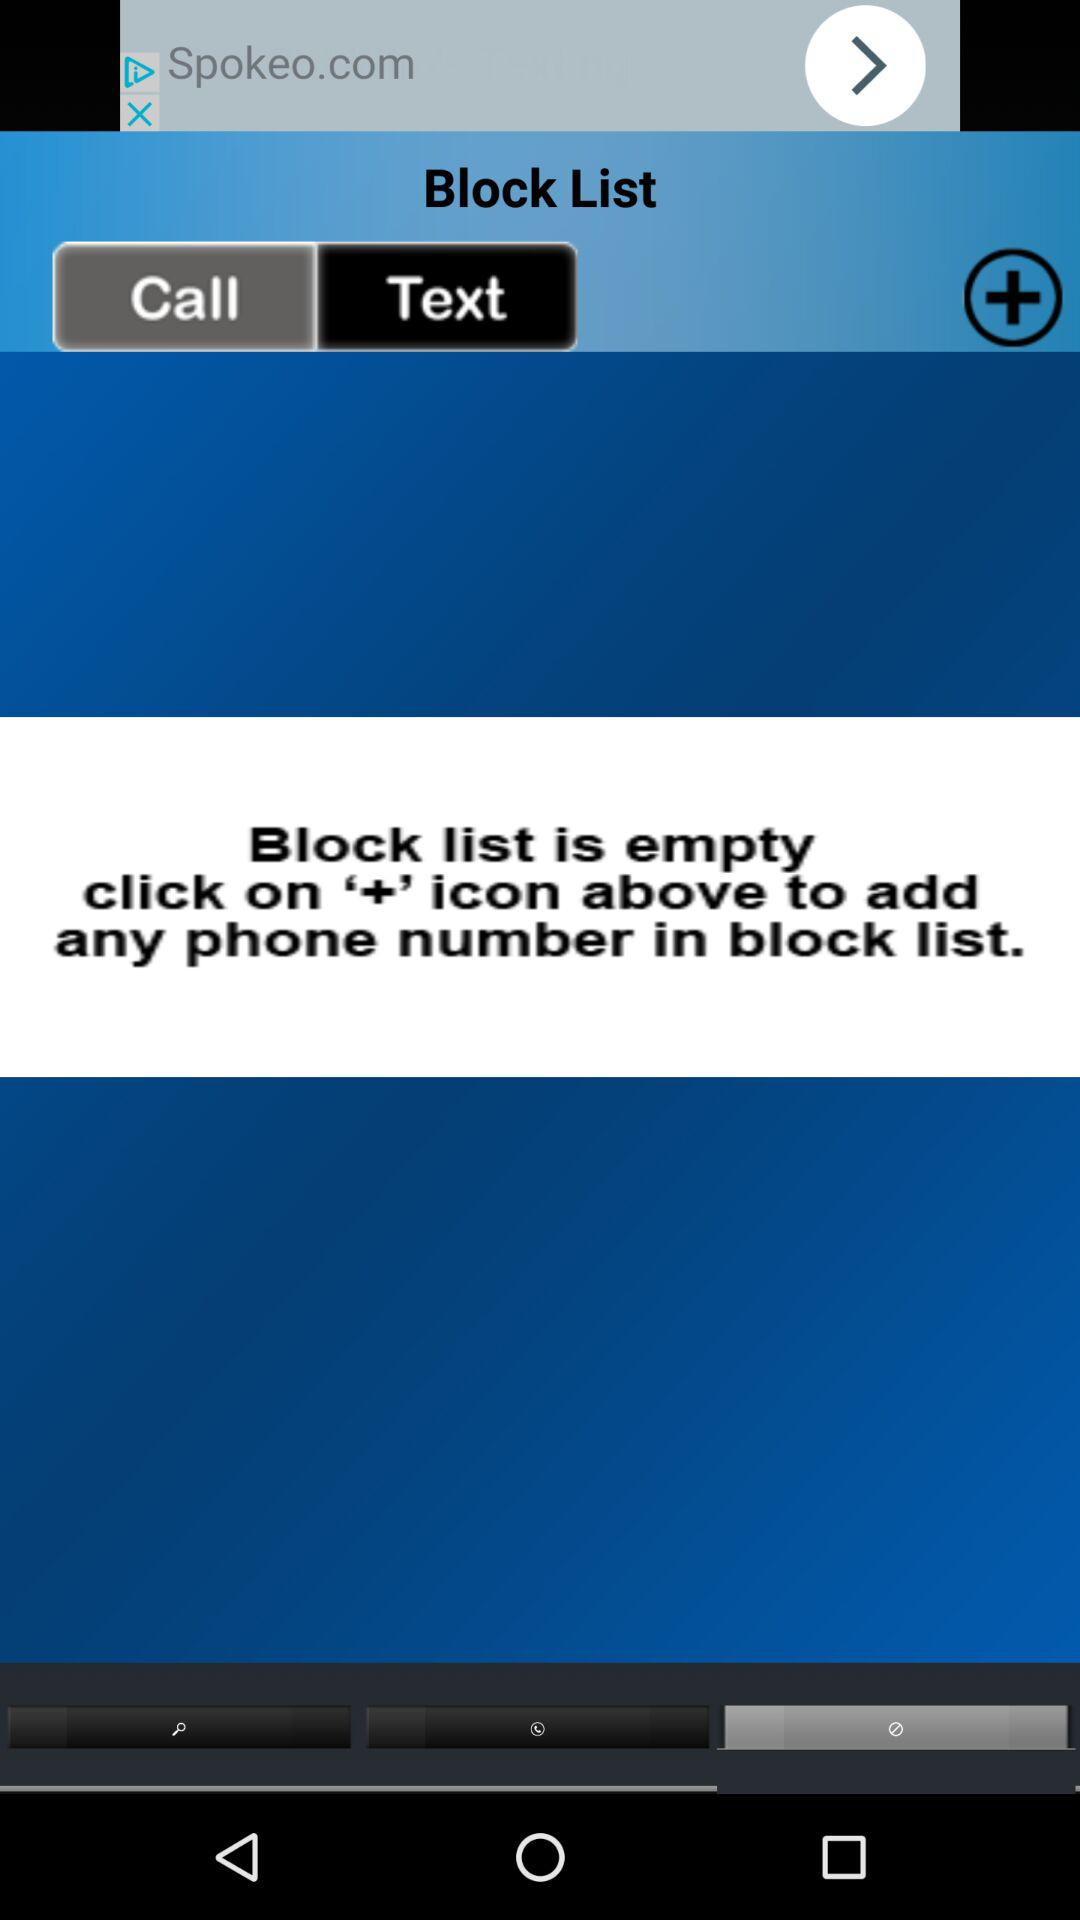Which phone numbers are added to the block list?
When the provided information is insufficient, respond with <no answer>. <no answer> 